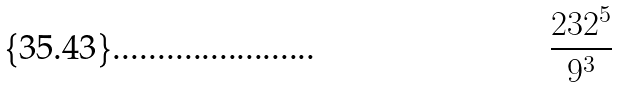Convert formula to latex. <formula><loc_0><loc_0><loc_500><loc_500>\frac { 2 3 2 ^ { 5 } } { 9 ^ { 3 } }</formula> 